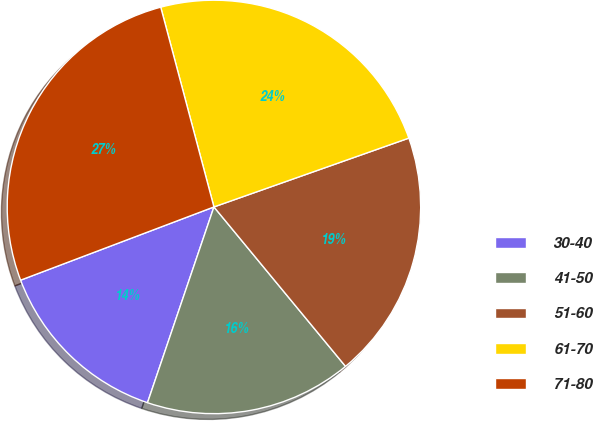Convert chart. <chart><loc_0><loc_0><loc_500><loc_500><pie_chart><fcel>30-40<fcel>41-50<fcel>51-60<fcel>61-70<fcel>71-80<nl><fcel>14.03%<fcel>16.19%<fcel>19.42%<fcel>23.74%<fcel>26.62%<nl></chart> 